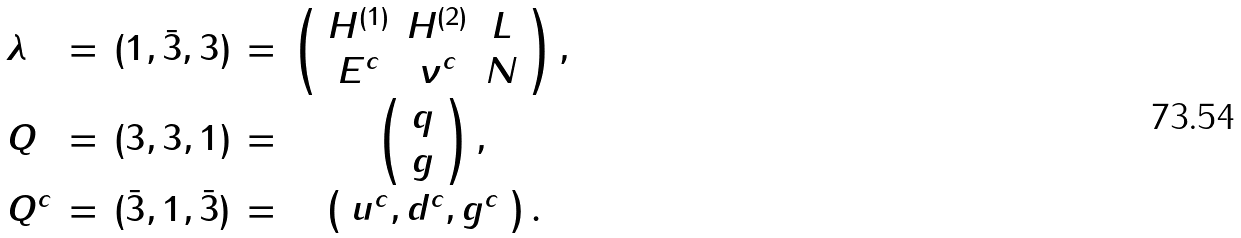<formula> <loc_0><loc_0><loc_500><loc_500>\begin{array} { l c c c c } \lambda & = & ( 1 , \bar { 3 } , 3 ) & = & \left ( \begin{array} { c c c } H ^ { ( 1 ) } & H ^ { ( 2 ) } & L \\ E ^ { c } & \nu ^ { c } & N \end{array} \right ) , \strut \\ Q & = & ( 3 , 3 , 1 ) & = & \left ( \begin{array} { c } q \\ g \end{array} \right ) , \strut \\ Q ^ { c } & = & ( \bar { 3 } , 1 , \bar { 3 } ) & = & \left ( \begin{array} { c } u ^ { c } , d ^ { c } , g ^ { c } \end{array} \right ) . \end{array}</formula> 